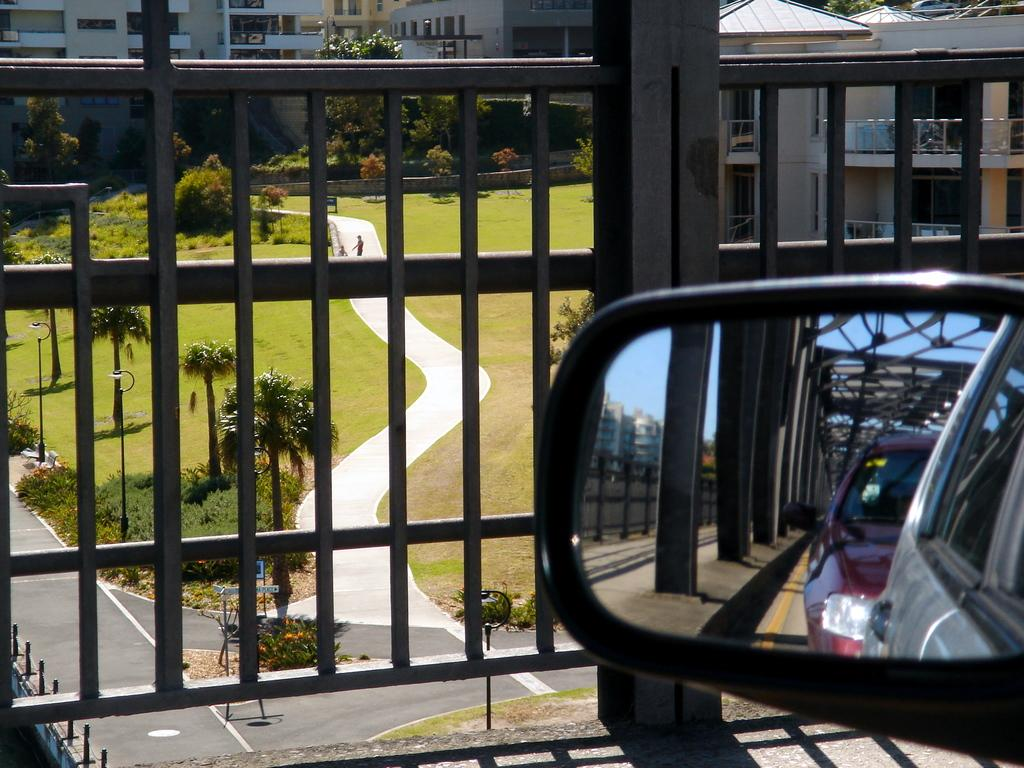What object in the image reflects the surroundings? There is a mirror in the image that reflects two vehicles on the road. What type of structures can be seen in the image? There are buildings in the image. What type of vegetation is present in the image? Plants, grass, and trees are visible in the image. What architectural feature can be seen in the image? Iron grills are present in the image. What part of the natural environment is visible in the image? The sky is visible in the image. How many dimes are scattered on the grass in the image? There are no dimes present in the image; it features a mirror, vehicles, buildings, vegetation, iron grills, and the sky. What type of tub is visible in the image? There is no tub present in the image. 